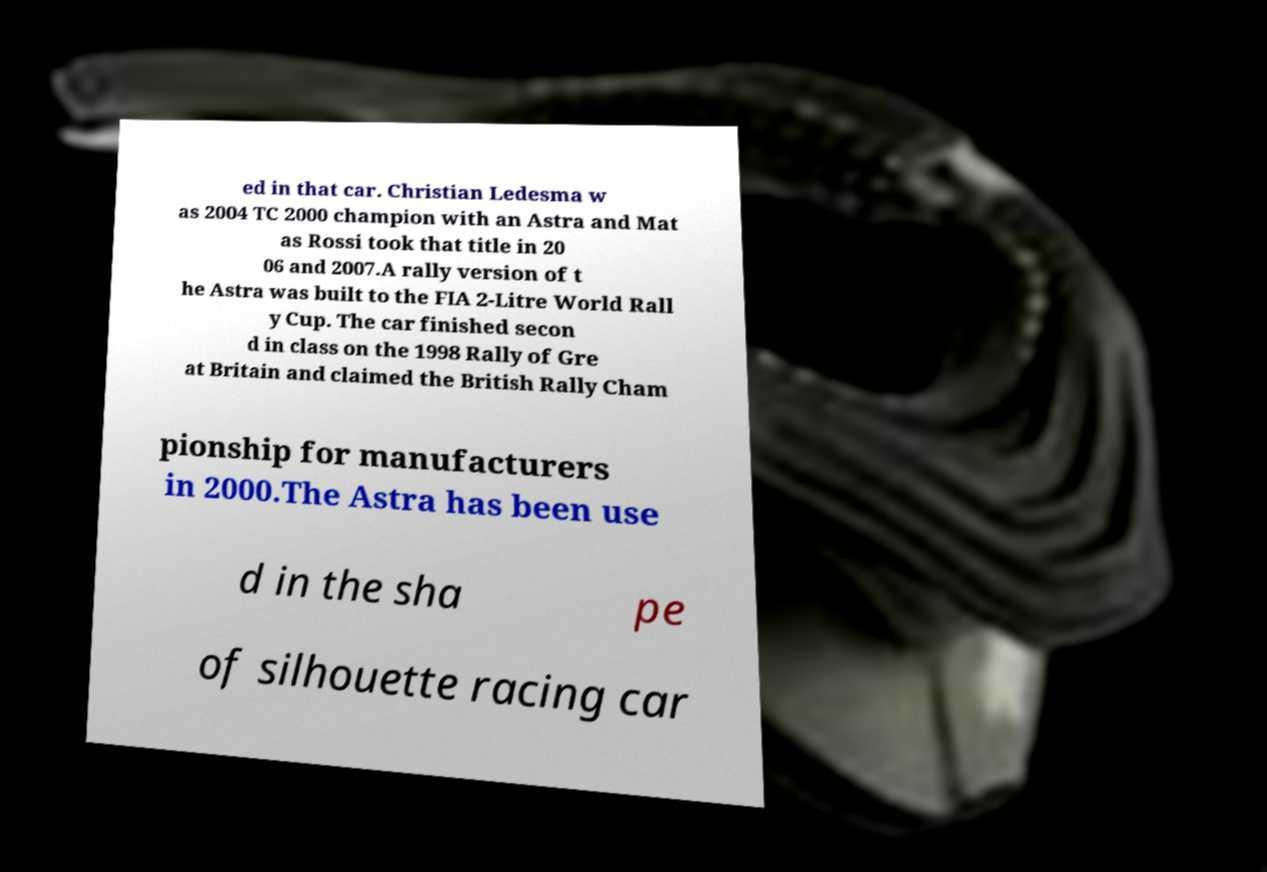I need the written content from this picture converted into text. Can you do that? ed in that car. Christian Ledesma w as 2004 TC 2000 champion with an Astra and Mat as Rossi took that title in 20 06 and 2007.A rally version of t he Astra was built to the FIA 2-Litre World Rall y Cup. The car finished secon d in class on the 1998 Rally of Gre at Britain and claimed the British Rally Cham pionship for manufacturers in 2000.The Astra has been use d in the sha pe of silhouette racing car 